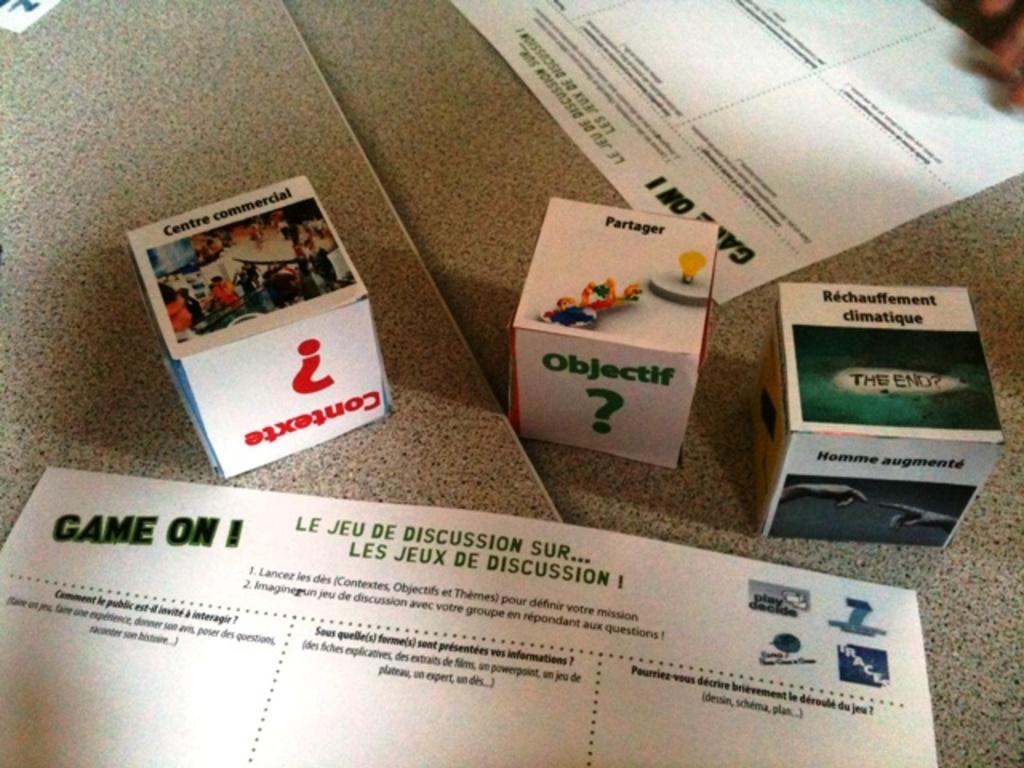<image>
Present a compact description of the photo's key features. a paper in front of small boxes with the 'game on 1' on it 